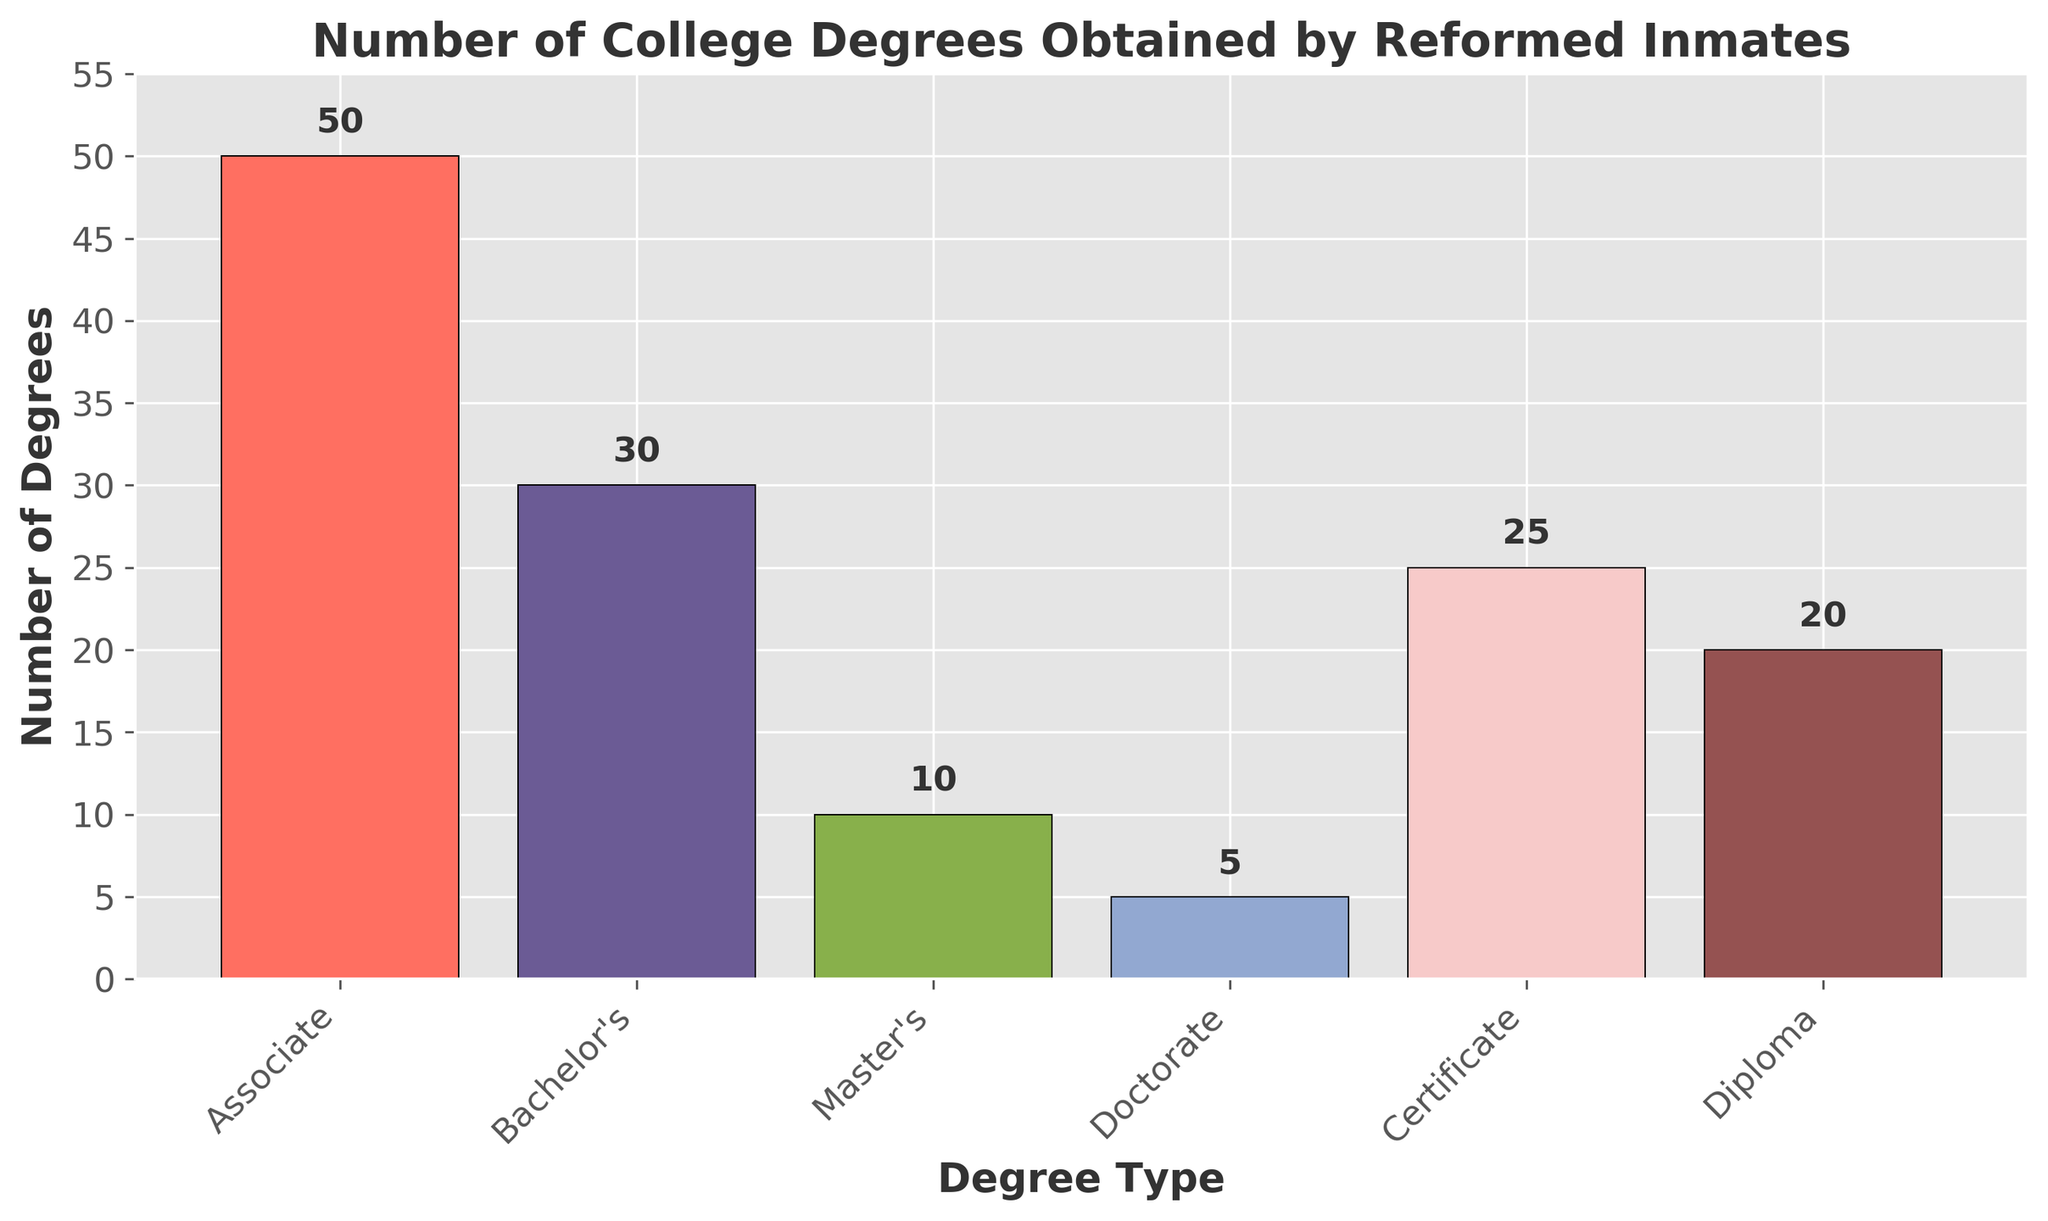How many more Associate degrees were obtained compared to Doctorate degrees? Associate degrees are represented by the first bar, with a height indicating 50 degrees. Doctorate degrees are represented by the fourth bar, with a height indicating 5 degrees. The difference is 50 - 5 = 45.
Answer: 45 Which type of degree was obtained the least? The height of the bar representing Doctorate degrees is the lowest compared to all other bars in the histogram, indicating it has the smallest number.
Answer: Doctorate What is the total number of degrees obtained by reformed inmates? Sum the heights of all the bars: Associate (50) + Bachelor's (30) + Master's (10) + Doctorate (5) + Certificate (25) + Diploma (20) = 140.
Answer: 140 How many degrees fall under postgraduate levels (Master's and Doctorate combined)? Add the number of Master's degrees and Doctorate degrees represented by the third and fourth bars, respectively: Master's (10) + Doctorate (5) = 15.
Answer: 15 Which degree type has the tallest bar in the histogram, indicating the highest frequency? The first bar representing Associate degrees is the tallest, indicating it has the highest number of degrees.
Answer: Associate What is the average number of degrees obtained across all degree types? The total number of degrees is 140, and there are 6 degree types. The average is calculated by dividing the total by the number of degree types: 140 / 6 = ~23.33.
Answer: ~23.33 How many degrees were obtained for non-degree certifications (Certificate and Diploma combined)? Add the number of Certificates and Diplomas as represented by the last two bars: Certificate (25) + Diploma (20) = 45.
Answer: 45 Is the number of Bachelor's degrees greater than the number of Diplomas? The second bar represents Bachelor's degrees and shows 30 degrees, while the last bar represents Diplomas and shows 20 degrees. Since 30 > 20, Bachelor's degrees are greater.
Answer: Yes Which degrees are fewer than 15 in number? By looking at the heights of the bars, both Master's (10) and Doctorate (5) degrees fall under this category.
Answer: Master's, Doctorate 